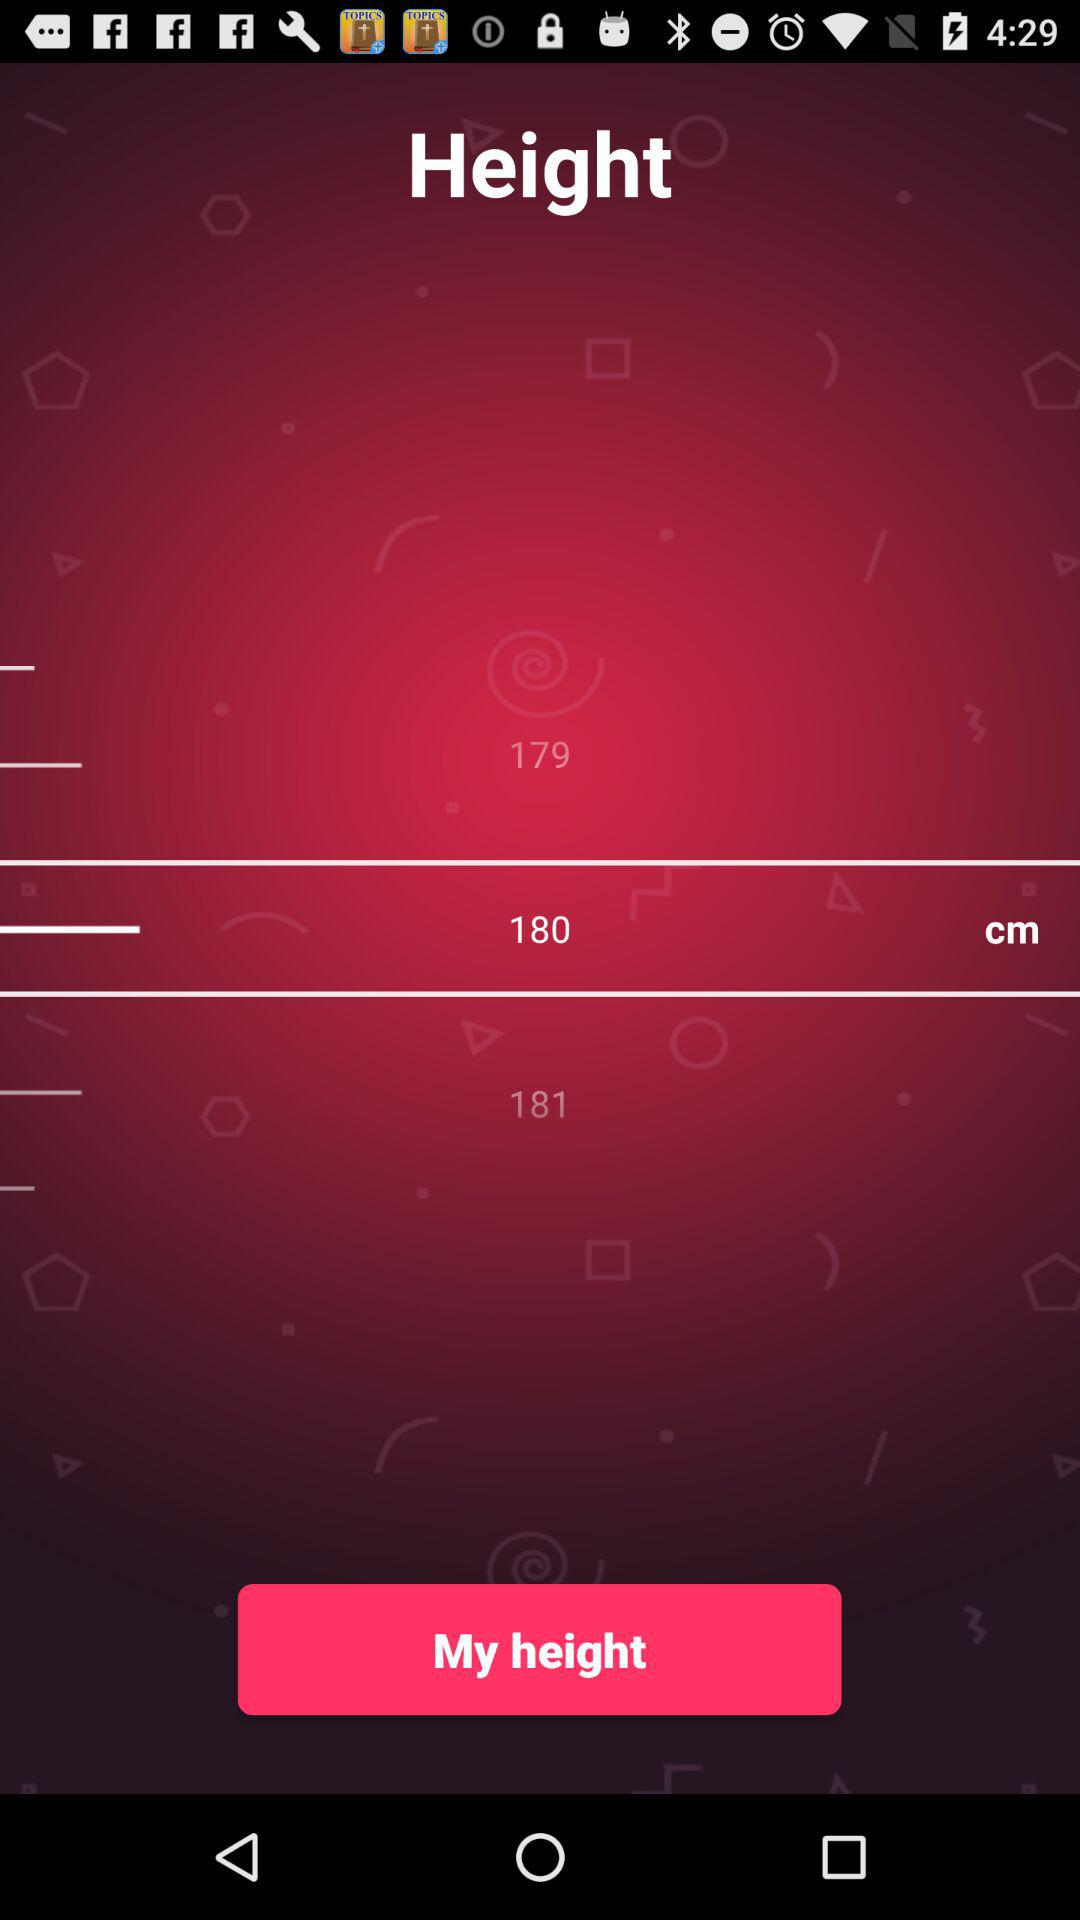How many cm is the difference between the height of 179 and 181?
Answer the question using a single word or phrase. 2 